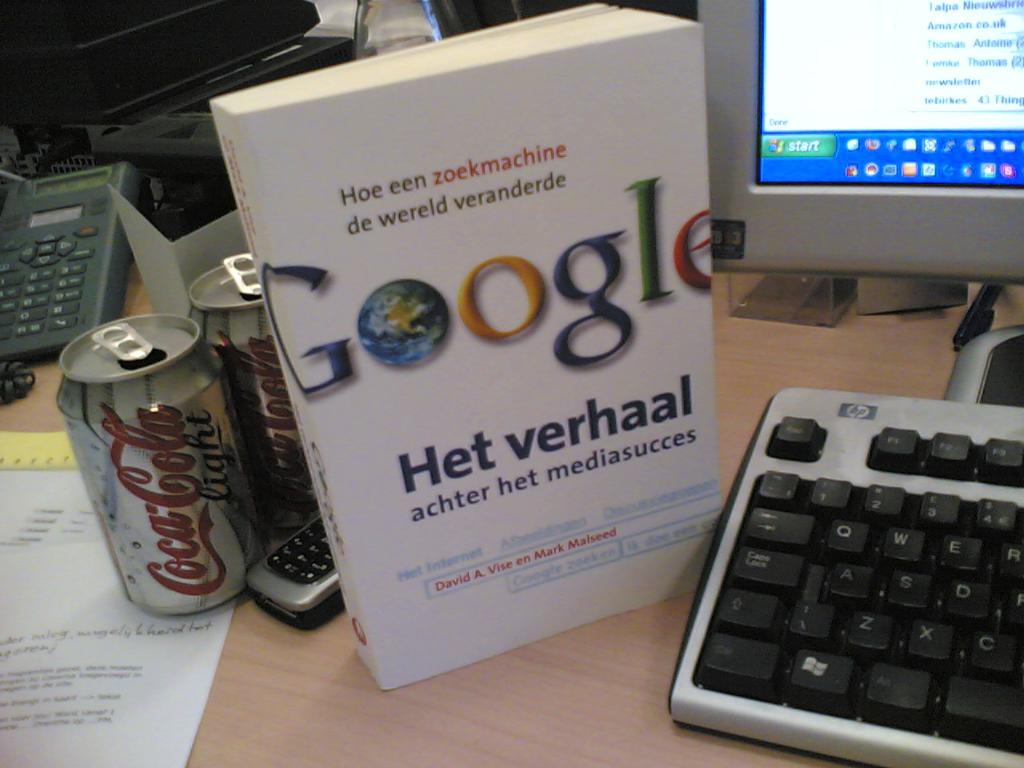Could you describe the overall mood or atmosphere this workspace conveys? This workspace exudes a sense of lived-in utility and informal productivity. The combination of personal items and work-related elements creates a casual yet focused atmosphere, likely conducive to extended periods of work. The presence of personal comforts, like the soft drink, alongside professional materials like the book and computer, suggests a blending of personal life and professional endeavors. 